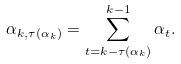Convert formula to latex. <formula><loc_0><loc_0><loc_500><loc_500>\alpha _ { k , \tau ( \alpha _ { k } ) } = \sum _ { t = k - \tau ( \alpha _ { k } ) } ^ { k - 1 } \alpha _ { t } .</formula> 